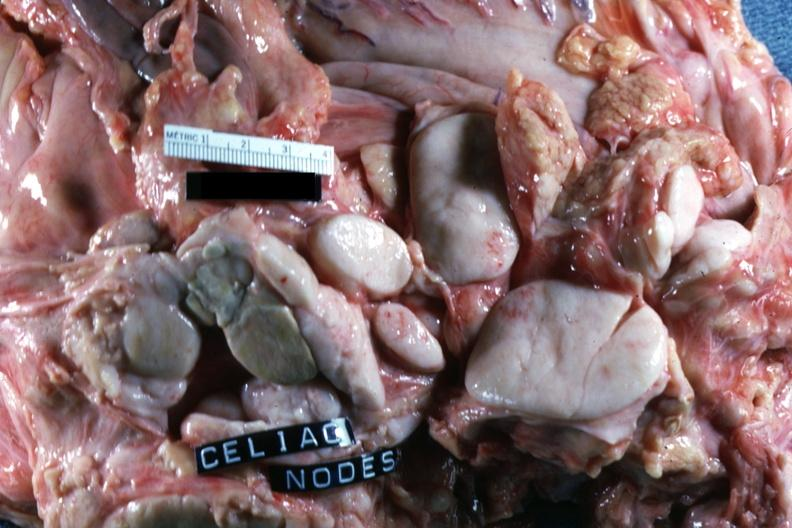what is present?
Answer the question using a single word or phrase. Lymph node 